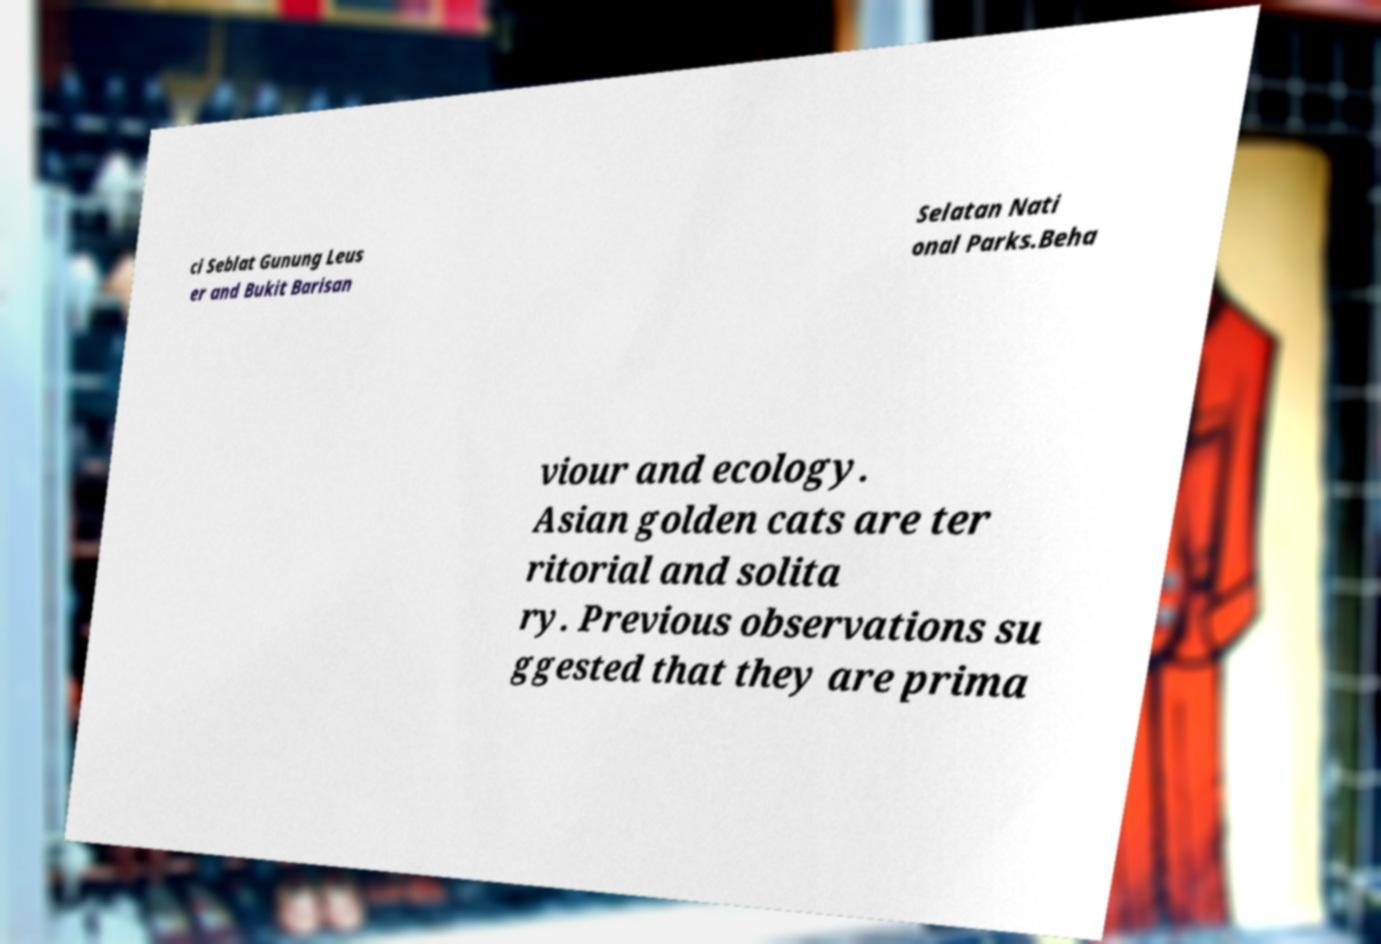Please read and relay the text visible in this image. What does it say? ci Seblat Gunung Leus er and Bukit Barisan Selatan Nati onal Parks.Beha viour and ecology. Asian golden cats are ter ritorial and solita ry. Previous observations su ggested that they are prima 